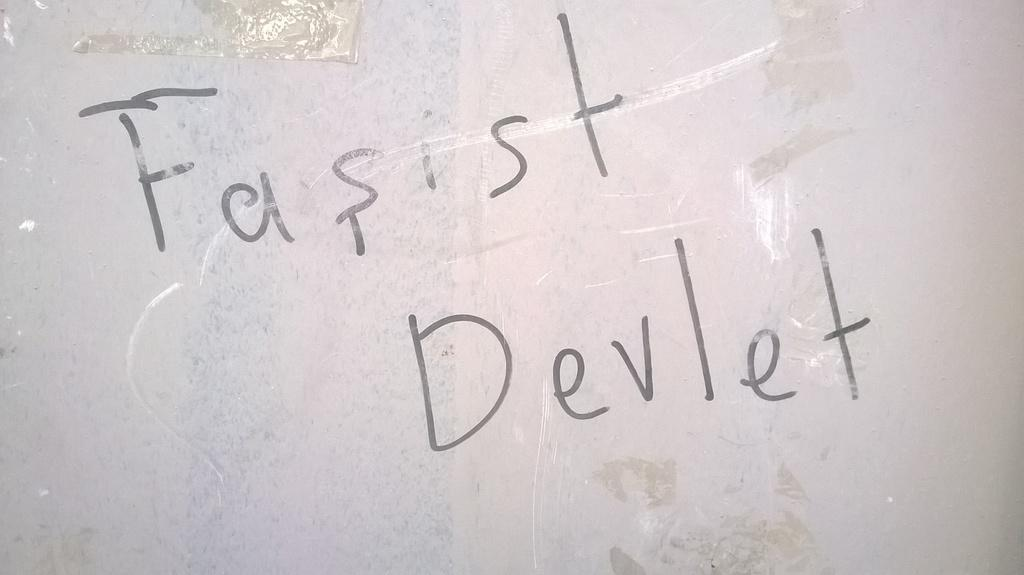<image>
Present a compact description of the photo's key features. The wall has "Fasist Devlet" written on it. 